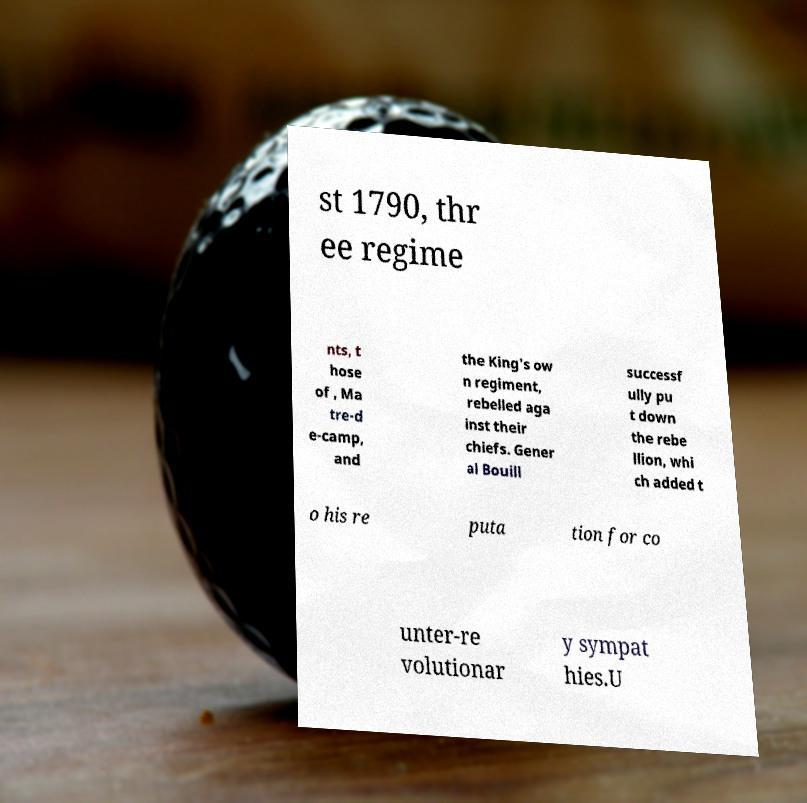For documentation purposes, I need the text within this image transcribed. Could you provide that? st 1790, thr ee regime nts, t hose of , Ma tre-d e-camp, and the King's ow n regiment, rebelled aga inst their chiefs. Gener al Bouill successf ully pu t down the rebe llion, whi ch added t o his re puta tion for co unter-re volutionar y sympat hies.U 